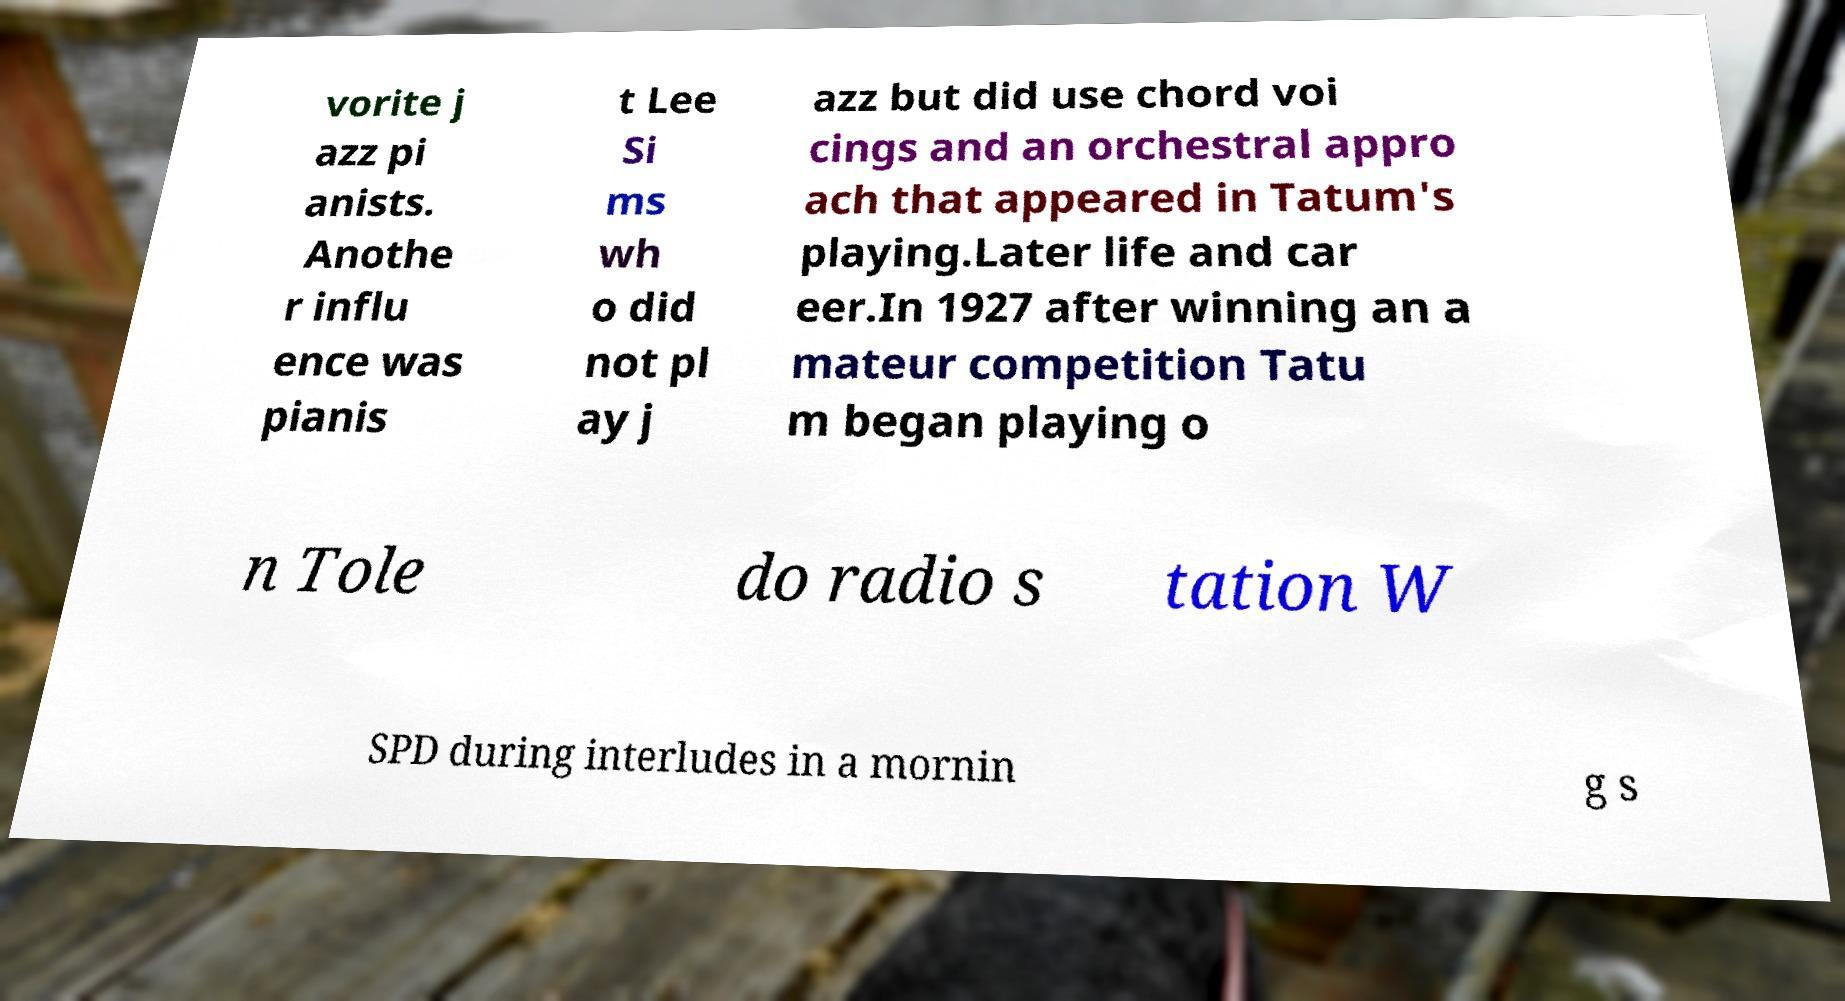Please identify and transcribe the text found in this image. vorite j azz pi anists. Anothe r influ ence was pianis t Lee Si ms wh o did not pl ay j azz but did use chord voi cings and an orchestral appro ach that appeared in Tatum's playing.Later life and car eer.In 1927 after winning an a mateur competition Tatu m began playing o n Tole do radio s tation W SPD during interludes in a mornin g s 